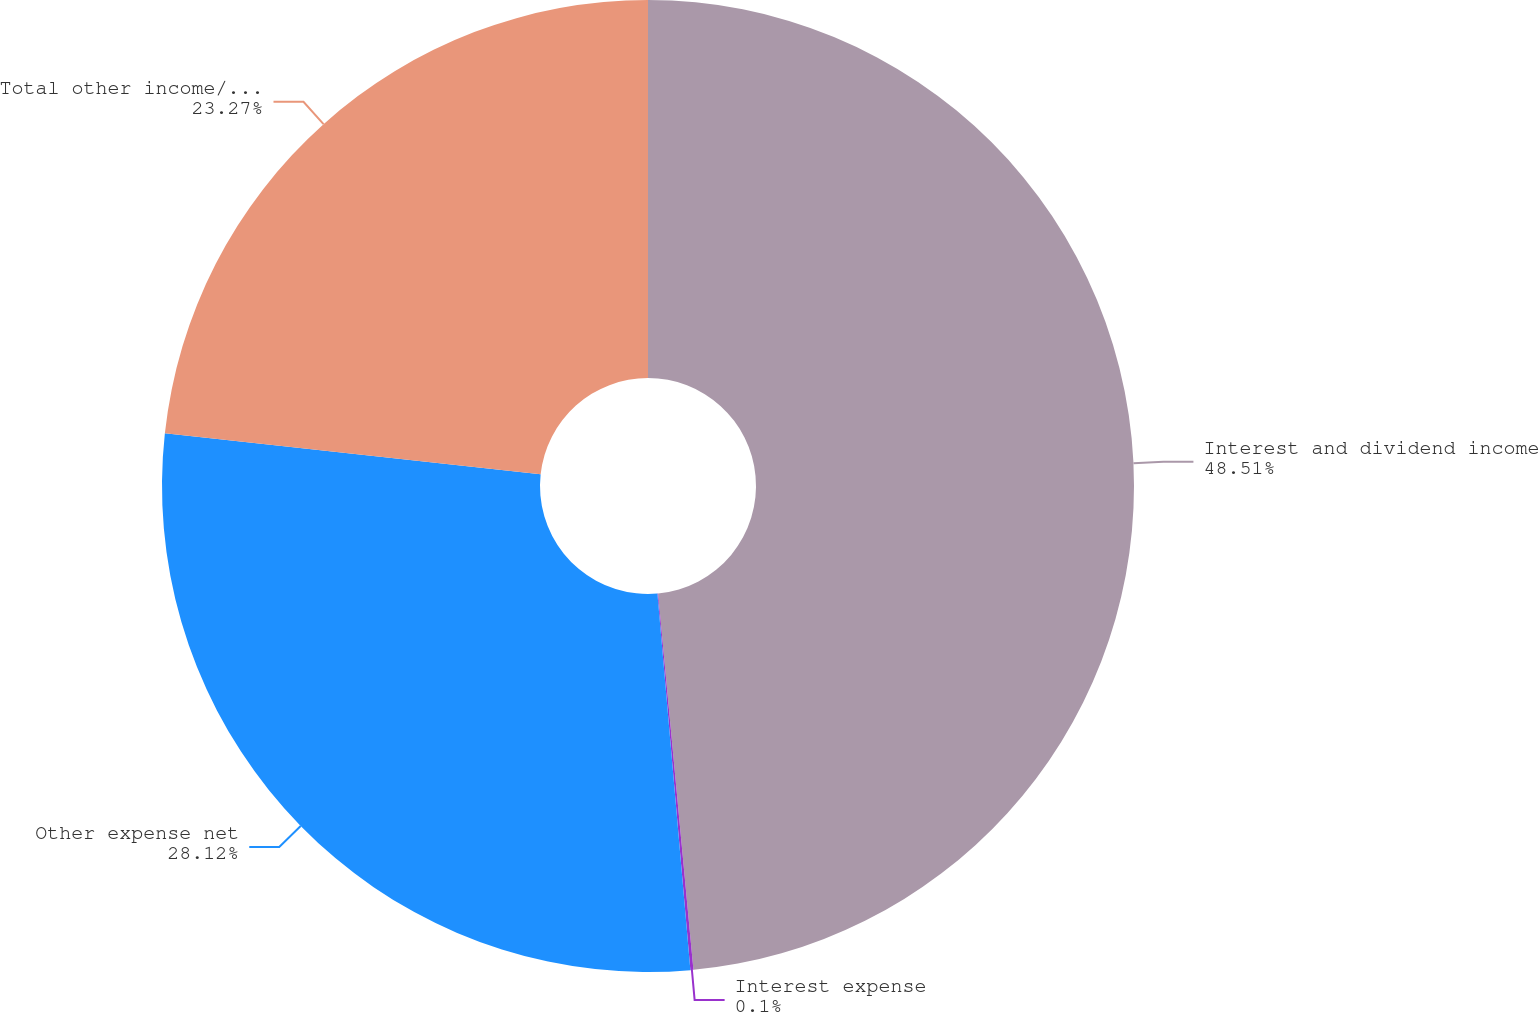<chart> <loc_0><loc_0><loc_500><loc_500><pie_chart><fcel>Interest and dividend income<fcel>Interest expense<fcel>Other expense net<fcel>Total other income/(expense)<nl><fcel>48.51%<fcel>0.1%<fcel>28.12%<fcel>23.27%<nl></chart> 